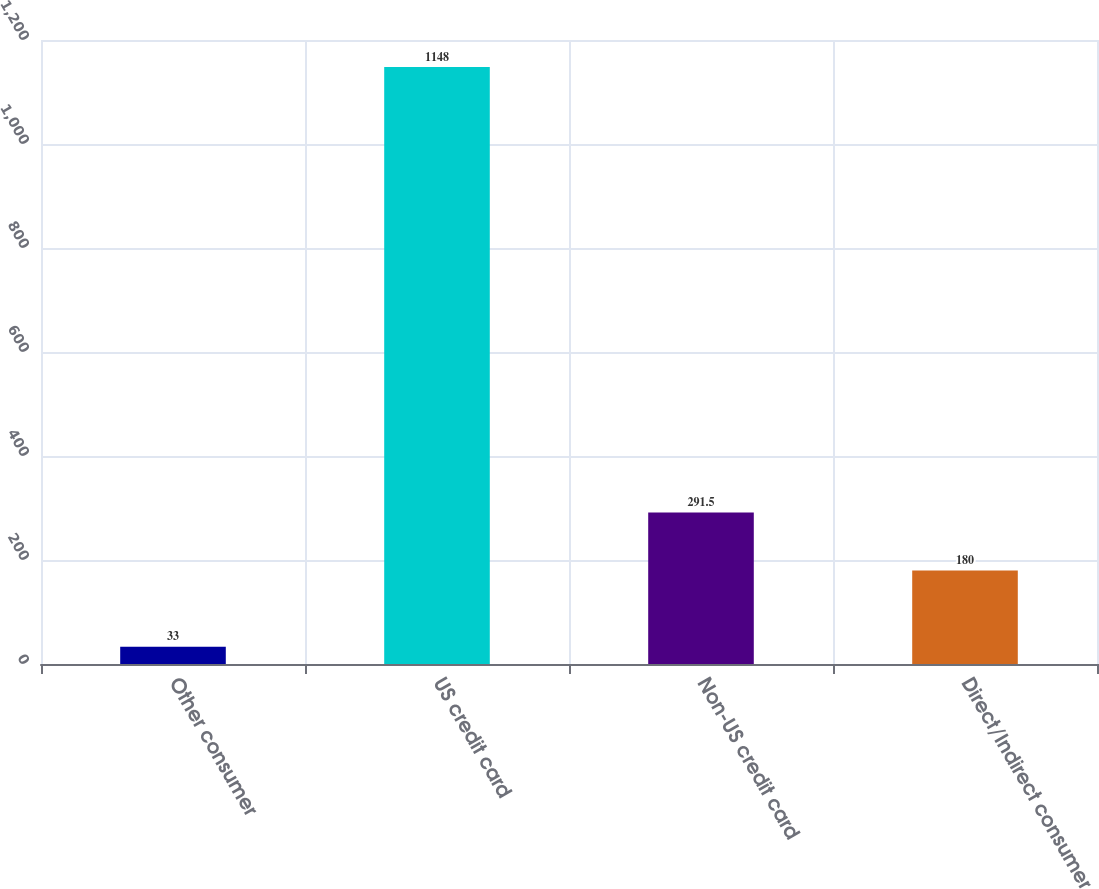<chart> <loc_0><loc_0><loc_500><loc_500><bar_chart><fcel>Other consumer<fcel>US credit card<fcel>Non-US credit card<fcel>Direct/Indirect consumer<nl><fcel>33<fcel>1148<fcel>291.5<fcel>180<nl></chart> 